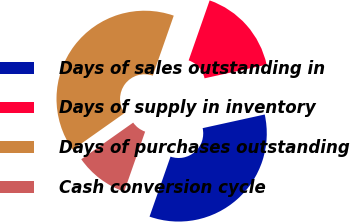<chart> <loc_0><loc_0><loc_500><loc_500><pie_chart><fcel>Days of sales outstanding in<fcel>Days of supply in inventory<fcel>Days of purchases outstanding<fcel>Cash conversion cycle<nl><fcel>33.8%<fcel>16.2%<fcel>40.14%<fcel>9.86%<nl></chart> 